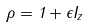<formula> <loc_0><loc_0><loc_500><loc_500>\rho = 1 + \epsilon I _ { z }</formula> 